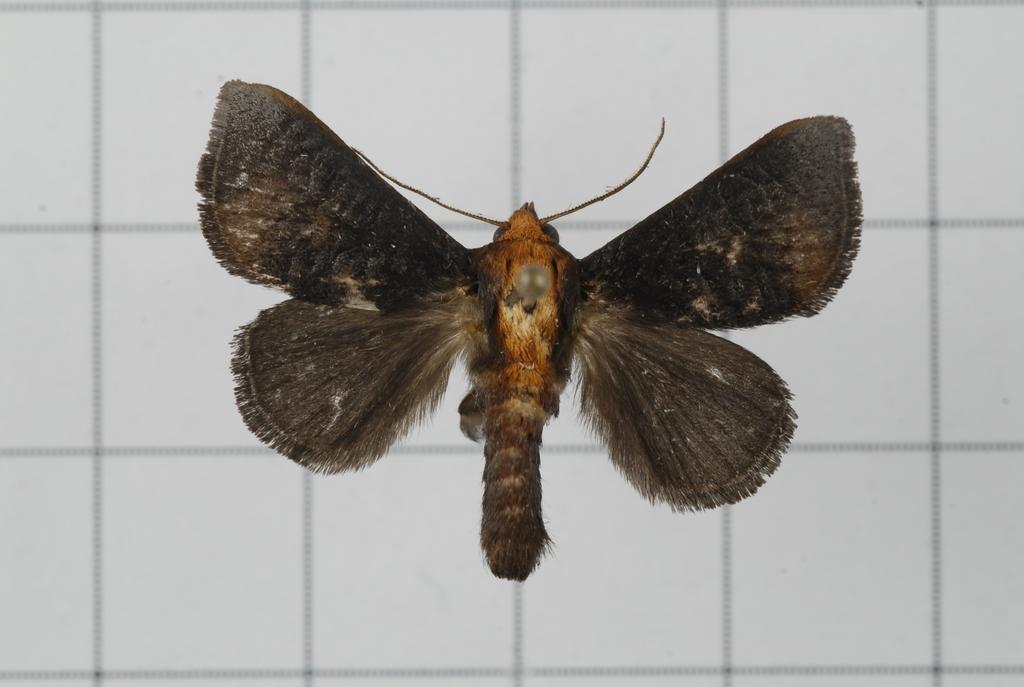Could you give a brief overview of what you see in this image? In the picture I can see an insect. The background of the image is white in color. 